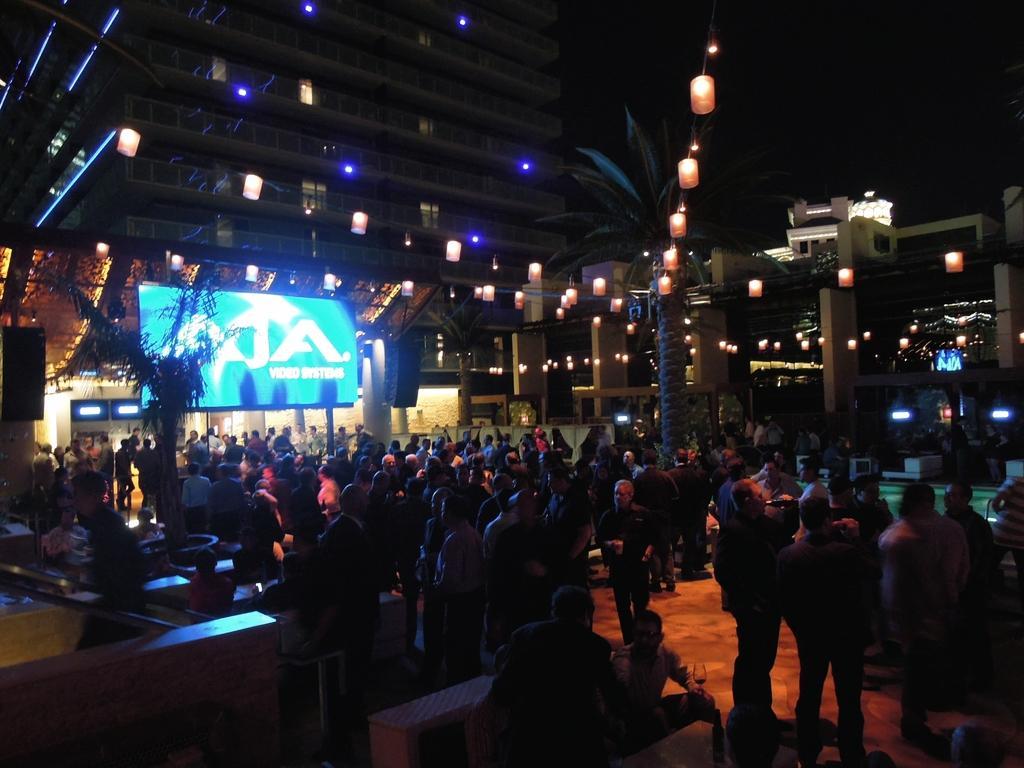Please provide a concise description of this image. It is an event,on the screen some image is being displayed and in front of the screen the crowd is standing and watching. The area is beautifully decorated with lights and behind the lights there is a building,in the background there is a sky. 